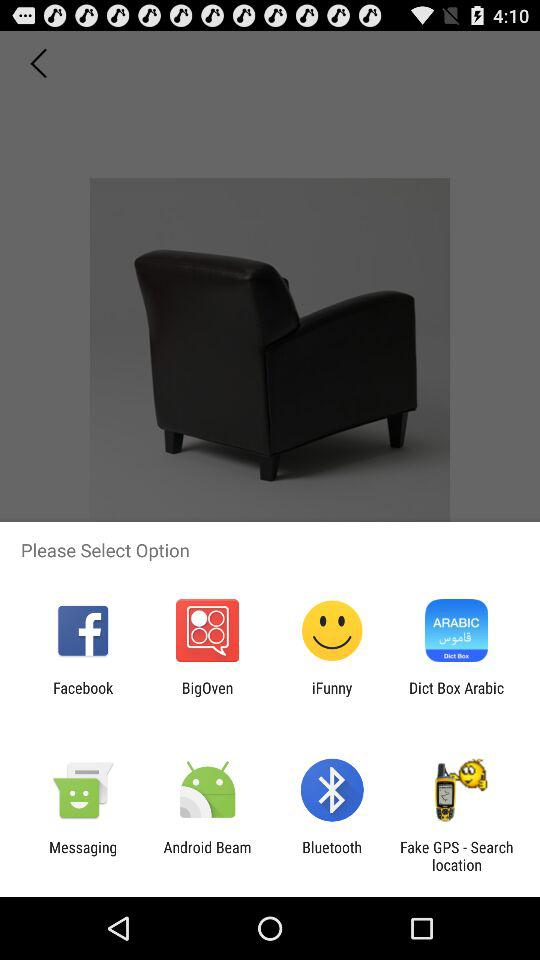Through which application can we share the image? You can share it with "Facebook", "BigOven", "iFunny", "Dict Box Arabic", "Messaging", "Android Beam", "Bluetooth" and "Fake GPS - Search location". 